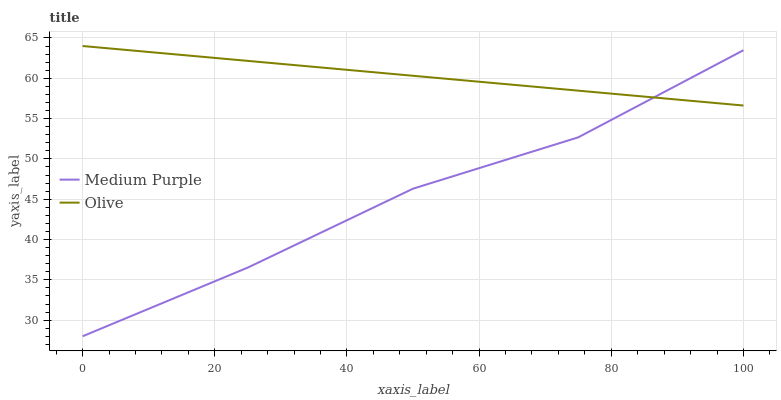Does Medium Purple have the minimum area under the curve?
Answer yes or no. Yes. Does Olive have the maximum area under the curve?
Answer yes or no. Yes. Does Olive have the minimum area under the curve?
Answer yes or no. No. Is Olive the smoothest?
Answer yes or no. Yes. Is Medium Purple the roughest?
Answer yes or no. Yes. Is Olive the roughest?
Answer yes or no. No. Does Olive have the lowest value?
Answer yes or no. No. 